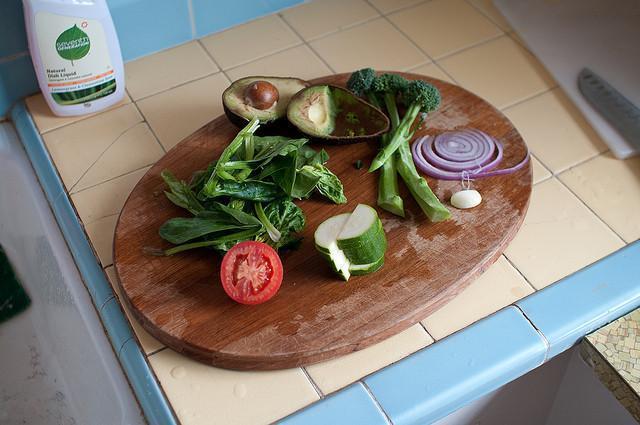How many bears are there?
Give a very brief answer. 0. 